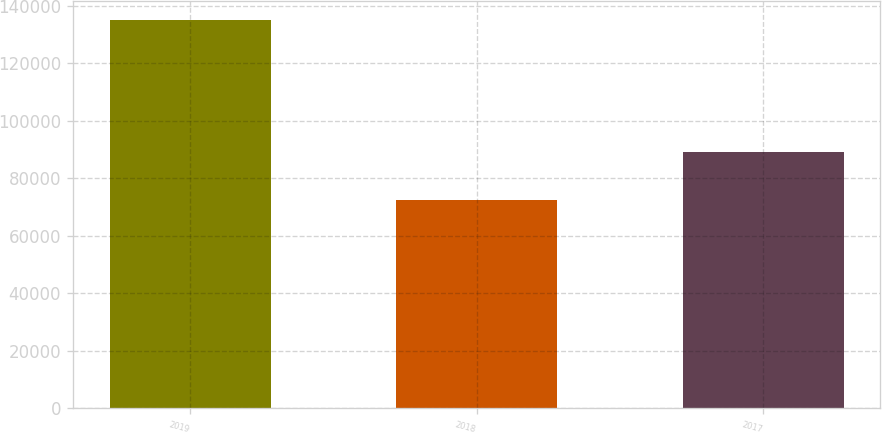Convert chart. <chart><loc_0><loc_0><loc_500><loc_500><bar_chart><fcel>2019<fcel>2018<fcel>2017<nl><fcel>134952<fcel>72454<fcel>89226<nl></chart> 